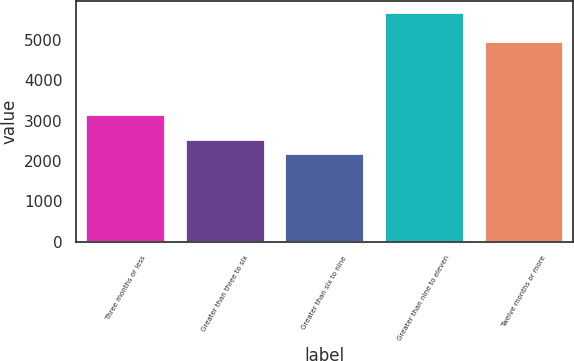Convert chart. <chart><loc_0><loc_0><loc_500><loc_500><bar_chart><fcel>Three months or less<fcel>Greater than three to six<fcel>Greater than six to nine<fcel>Greater than nine to eleven<fcel>Twelve months or more<nl><fcel>3153<fcel>2536.2<fcel>2186<fcel>5688<fcel>4989<nl></chart> 